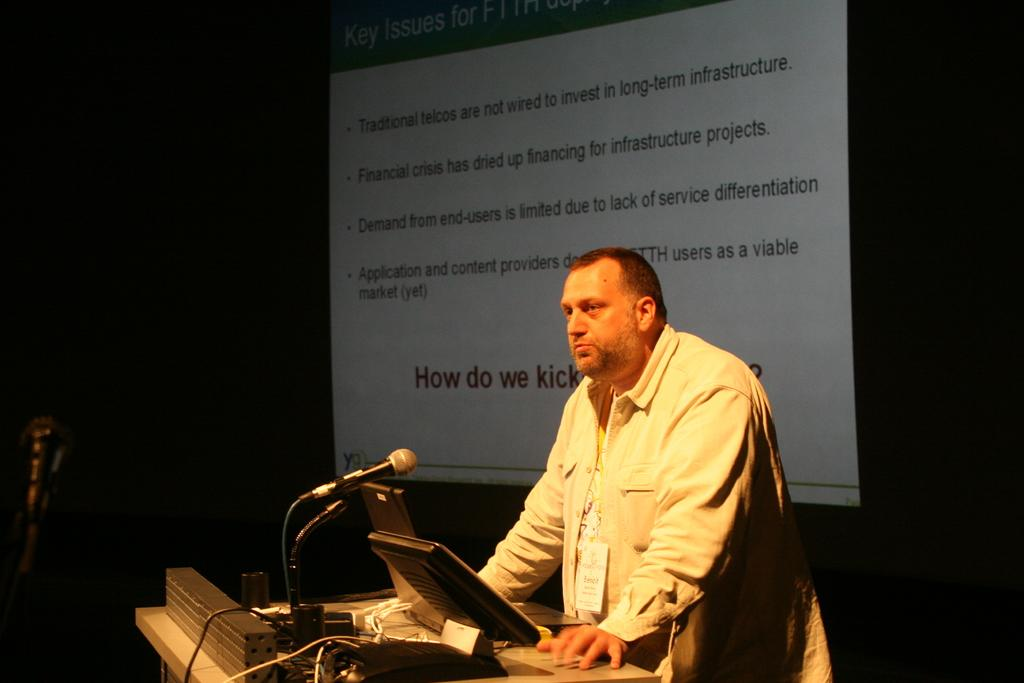Who or what is the main subject of the image? There is a person in the image. What is the person standing in front of? The person is in front of a podium. What is on the podium? The podium contains a monitor and a microphone. What is the large object in the middle of the image? There is a screen in the middle of the image. How many hens are visible on the screen in the image? There are no hens visible on the screen in the image. What type of card is being used by the person in the image? There is no card being used by the person in the image. 